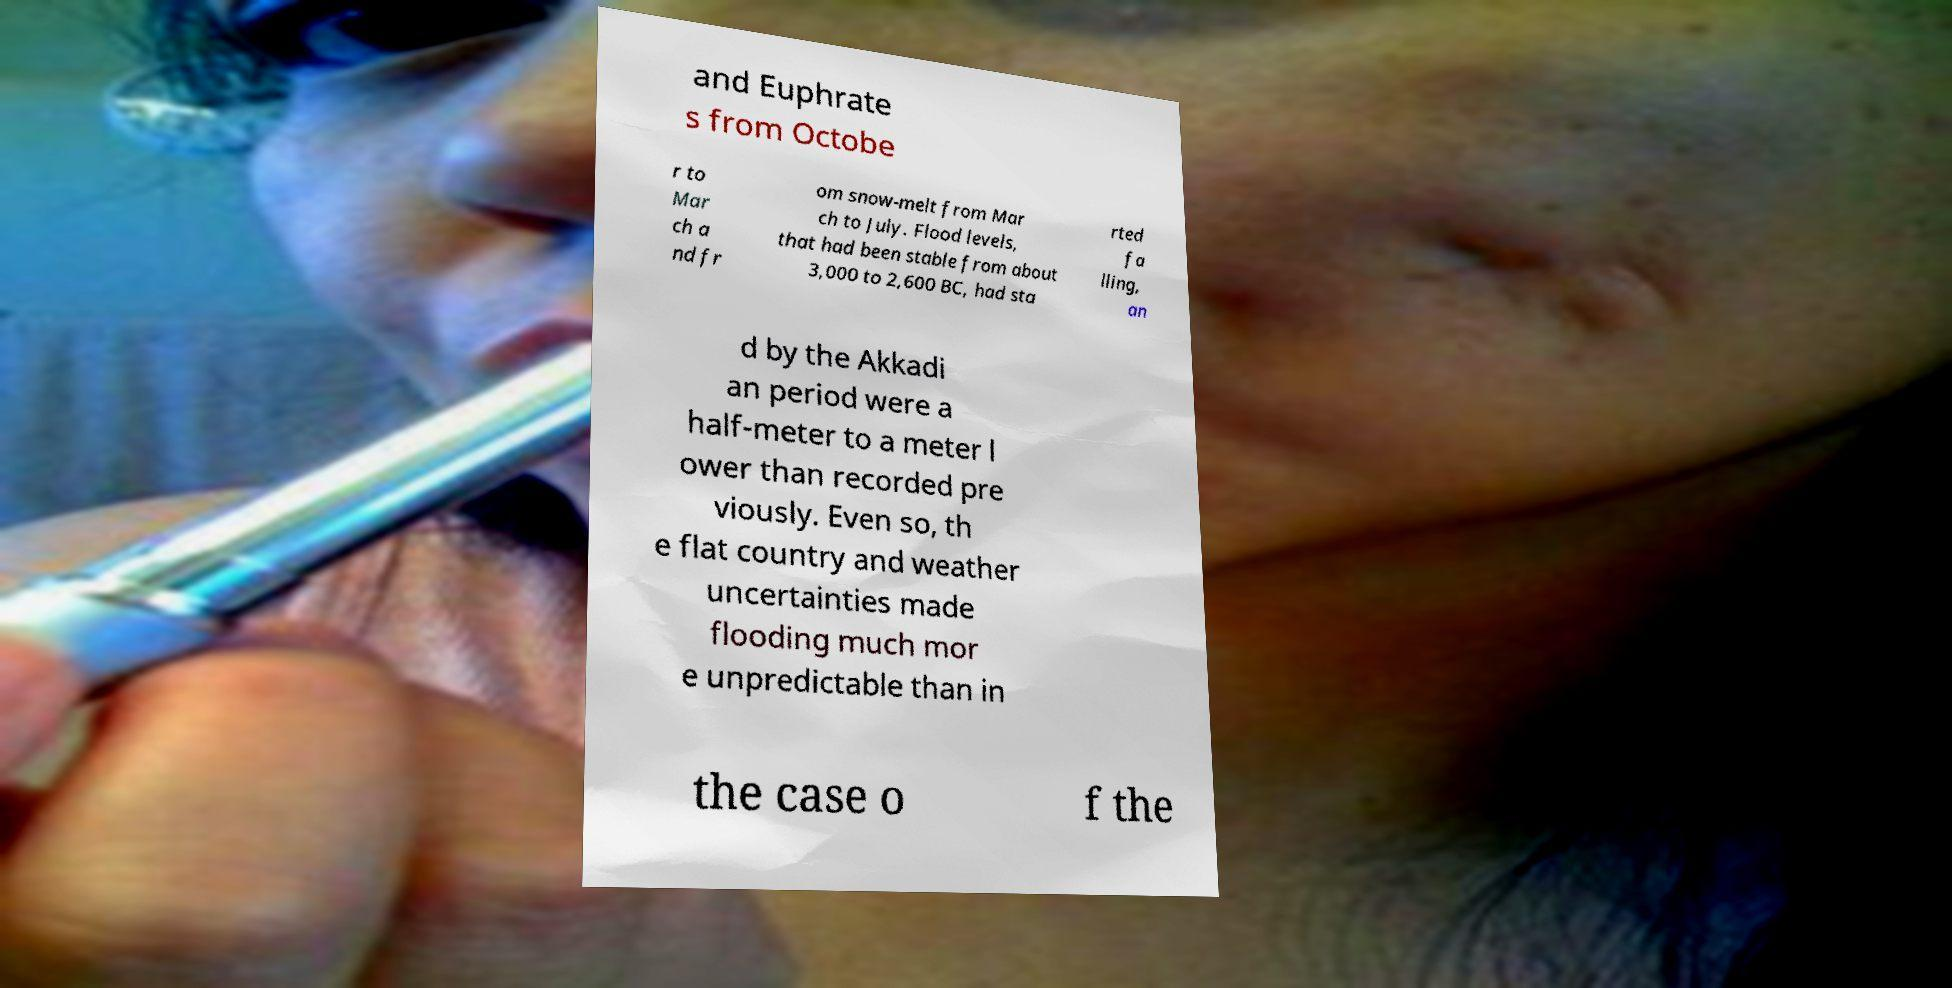I need the written content from this picture converted into text. Can you do that? and Euphrate s from Octobe r to Mar ch a nd fr om snow-melt from Mar ch to July. Flood levels, that had been stable from about 3,000 to 2,600 BC, had sta rted fa lling, an d by the Akkadi an period were a half-meter to a meter l ower than recorded pre viously. Even so, th e flat country and weather uncertainties made flooding much mor e unpredictable than in the case o f the 